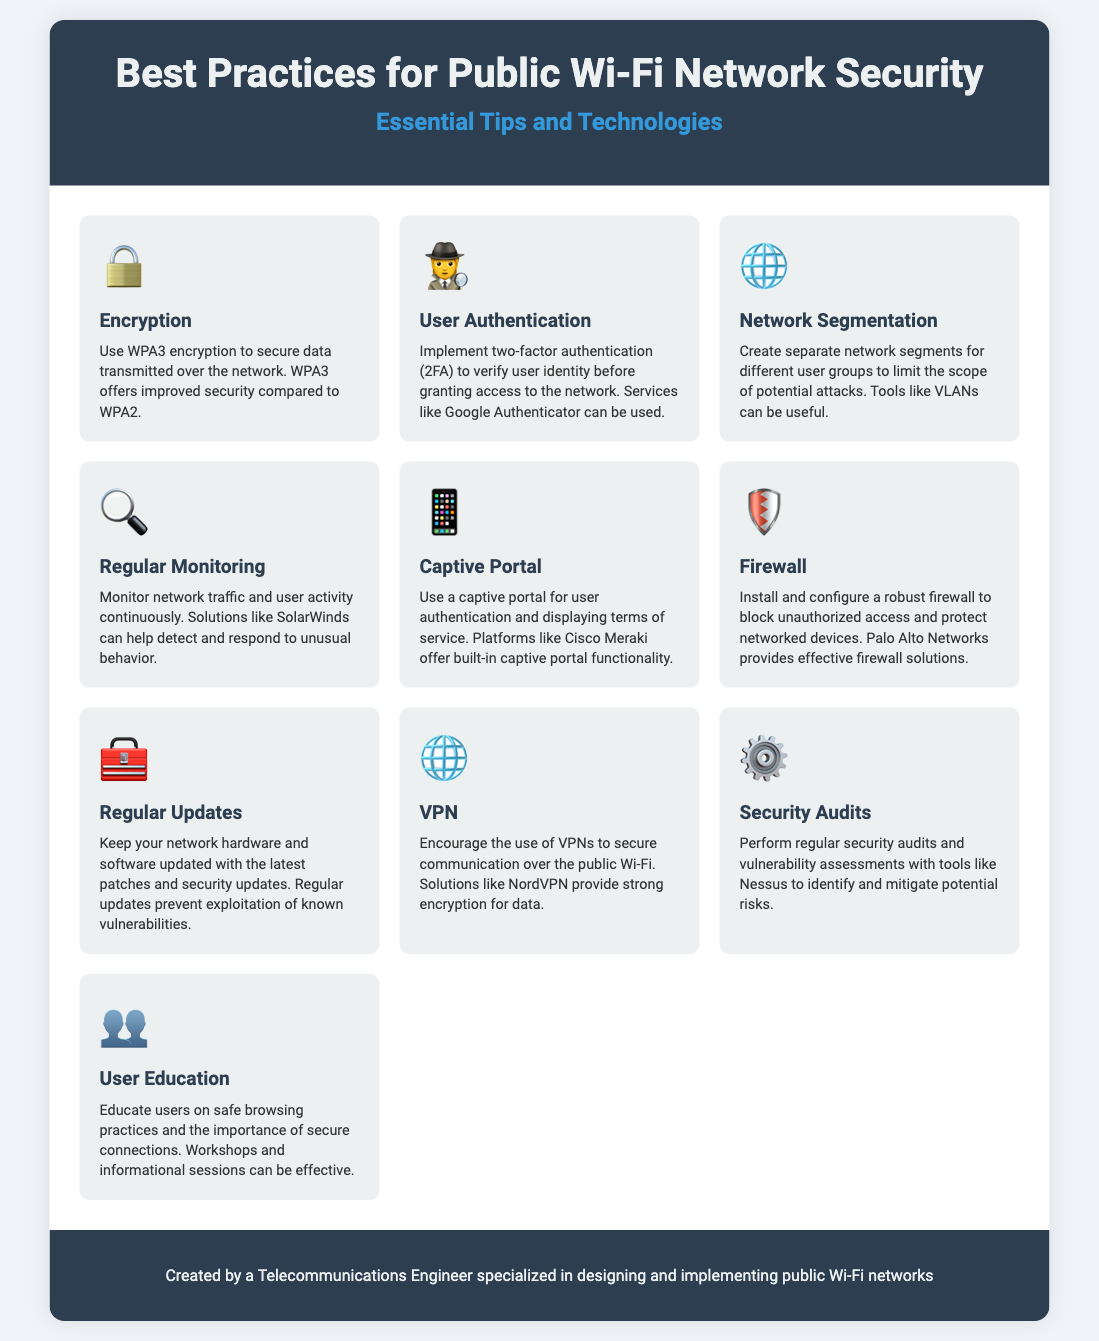What encryption method is recommended? The document states that WPA3 encryption is recommended for securing data transmitted over the network.
Answer: WPA3 What is a suggested tool for user authentication? The infographic suggests using Google Authenticator for implementing two-factor authentication.
Answer: Google Authenticator Which technology is suggested for network segmentation? The document mentions that VLANs can be useful for creating separate network segments for different user groups.
Answer: VLANs What is recommended for monitoring network activity? The document recommends using solutions like SolarWinds for continuous monitoring of network traffic and user activity.
Answer: SolarWinds What should be installed to block unauthorized access? The infographic states that a robust firewall should be installed and configured to block unauthorized access.
Answer: Firewall Which practice helps in educating users on secure practices? The document highlights that workshops and informational sessions are effective for user education on safe browsing practices.
Answer: Workshops What is a key practice to prevent exploitation of vulnerabilities? The infographic highlights that keeping network hardware and software updated with the latest patches is crucial.
Answer: Regular Updates What technology is encouraged to secure communication over public Wi-Fi? The document encourages the use of VPNs to secure communication over public Wi-Fi.
Answer: VPN What is essential for identifying potential risks? The infographic states that performing regular security audits and vulnerability assessments is essential to identify potential risks.
Answer: Security Audits What visual element is used to present each best practice? Each best practice is presented with an icon that represents the specific security tip or technology.
Answer: Icons 